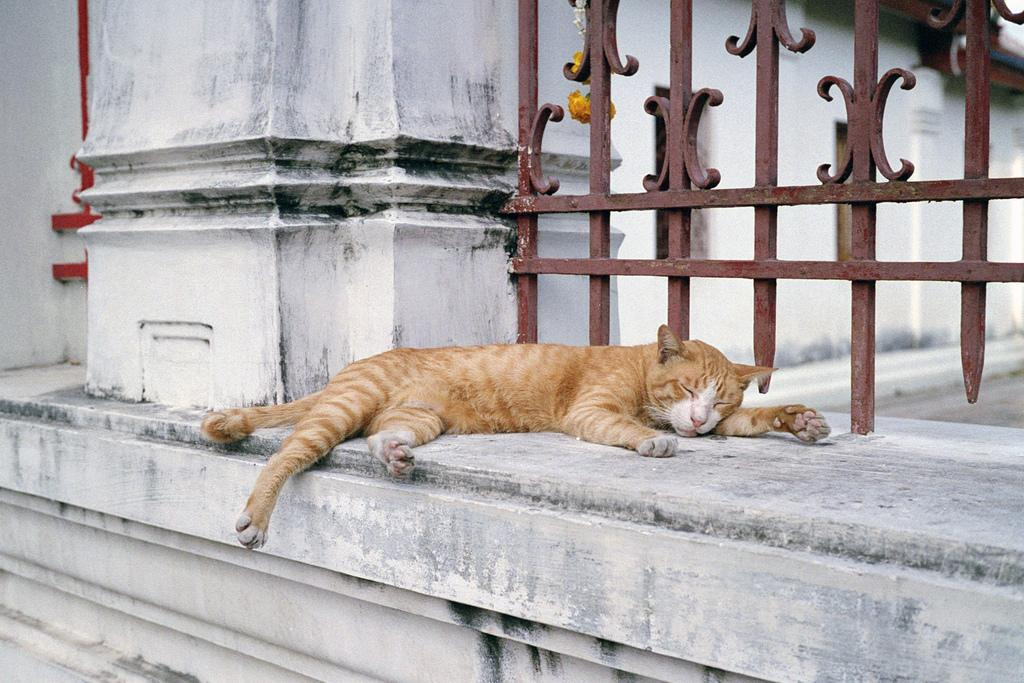What color is the cat in the image? The cat in the image is gold in color. What is the cat doing in the image? The cat is sleeping in the image. Where is the cat located in the image? The cat is on a wall in the image. What is behind the cat in the image? There is a railing behind the cat in the image. How many rings can be seen on the cat's eye in the image? There are no rings visible on the cat's eye in the image, as the cat's eyes are not shown in the image. 